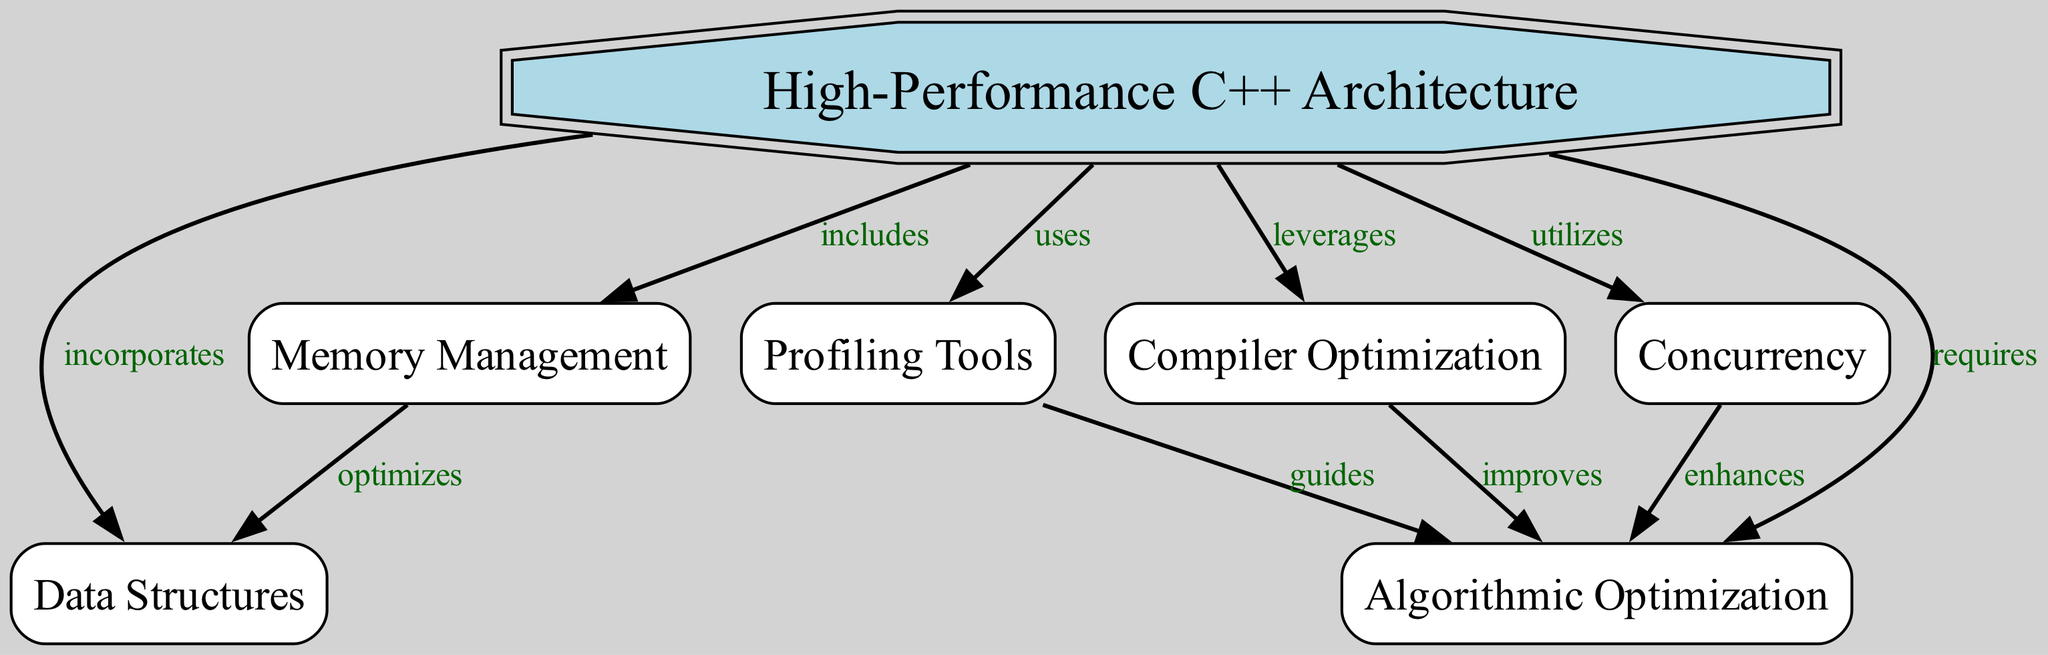What is the primary focus of this diagram? The diagram centers around "High-Performance C++ Architecture" as the main node, indicating its significance in the context of software architecture. Thus, this node is labeled as such at the top of the diagram.
Answer: High-Performance C++ Architecture How many nodes are included in the diagram? By counting the individual nodes listed in the data section, there are a total of seven nodes illustrated within the diagram, which represent different components of the architecture.
Answer: 7 What component does "Memory Management" optimize? According to the edge labeled "optimizes," there is a direct link from "Memory Management" to "Data Structures," indicating that effective memory management optimizes the usage of data structures in C++ software architecture.
Answer: Data Structures Which component enhances concurrency? The edge labeled "enhances" connects "Concurrency" to "Algorithmic Optimization," suggesting that improvements in concurrency lead to better algorithmic optimization within the architecture.
Answer: Algorithmic Optimization How does the architecture leverage compiler optimization? The diagram indicates that "Compiler Optimization" is linked with "Algorithmic Optimization" through the edge labeled "improves," which means it facilitates enhanced performance of algorithms within the architecture.
Answer: Improves Which component guides algorithmic optimization according to the diagram? The diagram shows a direct relationship denoted by the edge labeled "guides" between "Profiling Tools" and "Algorithmic Optimization," implying that profiling tools provide insights that guide the process of optimizing algorithms.
Answer: Profiling Tools What relationship does "Memory Management" have with "Concurrency"? There is no direct edge connecting "Memory Management" and "Concurrency" in the diagram, indicating that while both are components of high-performance architecture, they do not have a direct relationship in the context represented here.
Answer: None 